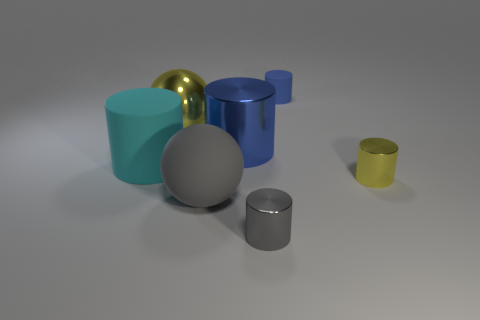Subtract all large cyan rubber cylinders. How many cylinders are left? 4 Add 2 yellow things. How many objects exist? 9 Subtract all gray spheres. How many spheres are left? 1 Subtract 1 balls. How many balls are left? 1 Subtract all blue cylinders. How many brown balls are left? 0 Subtract all small metallic objects. Subtract all tiny yellow metallic things. How many objects are left? 4 Add 5 small yellow metal cylinders. How many small yellow metal cylinders are left? 6 Add 4 green matte cylinders. How many green matte cylinders exist? 4 Subtract 0 cyan blocks. How many objects are left? 7 Subtract all cylinders. How many objects are left? 2 